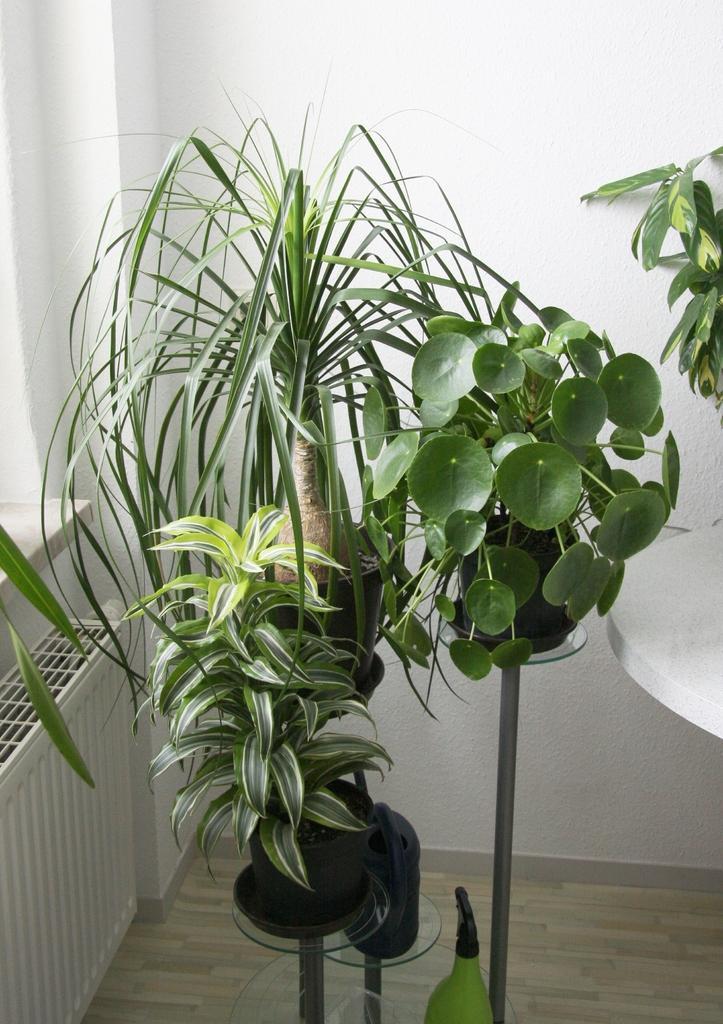Describe this image in one or two sentences. In the picture we can find a plant in the house placed on the floor, beside to that there is a wall and a window. 